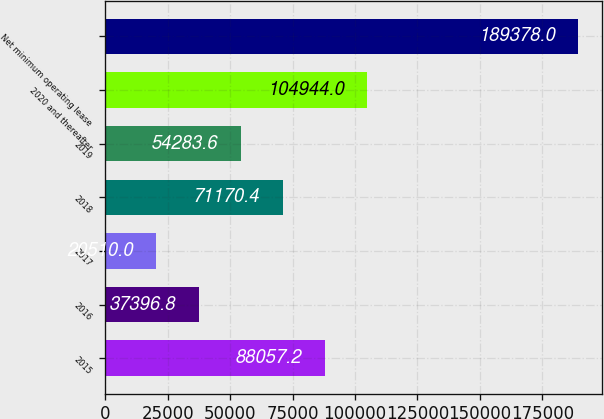Convert chart. <chart><loc_0><loc_0><loc_500><loc_500><bar_chart><fcel>2015<fcel>2016<fcel>2017<fcel>2018<fcel>2019<fcel>2020 and thereafter<fcel>Net minimum operating lease<nl><fcel>88057.2<fcel>37396.8<fcel>20510<fcel>71170.4<fcel>54283.6<fcel>104944<fcel>189378<nl></chart> 